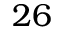<formula> <loc_0><loc_0><loc_500><loc_500>2 6</formula> 